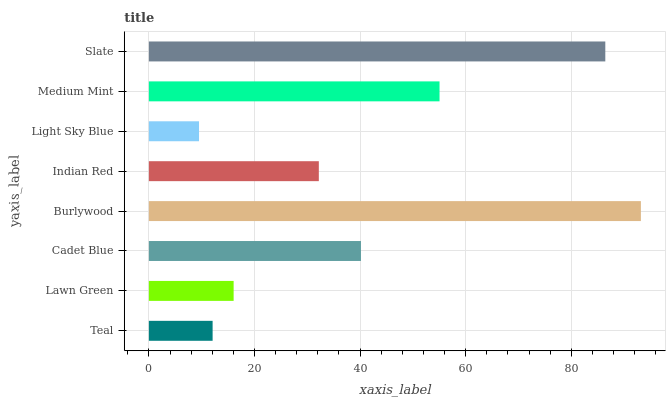Is Light Sky Blue the minimum?
Answer yes or no. Yes. Is Burlywood the maximum?
Answer yes or no. Yes. Is Lawn Green the minimum?
Answer yes or no. No. Is Lawn Green the maximum?
Answer yes or no. No. Is Lawn Green greater than Teal?
Answer yes or no. Yes. Is Teal less than Lawn Green?
Answer yes or no. Yes. Is Teal greater than Lawn Green?
Answer yes or no. No. Is Lawn Green less than Teal?
Answer yes or no. No. Is Cadet Blue the high median?
Answer yes or no. Yes. Is Indian Red the low median?
Answer yes or no. Yes. Is Light Sky Blue the high median?
Answer yes or no. No. Is Cadet Blue the low median?
Answer yes or no. No. 